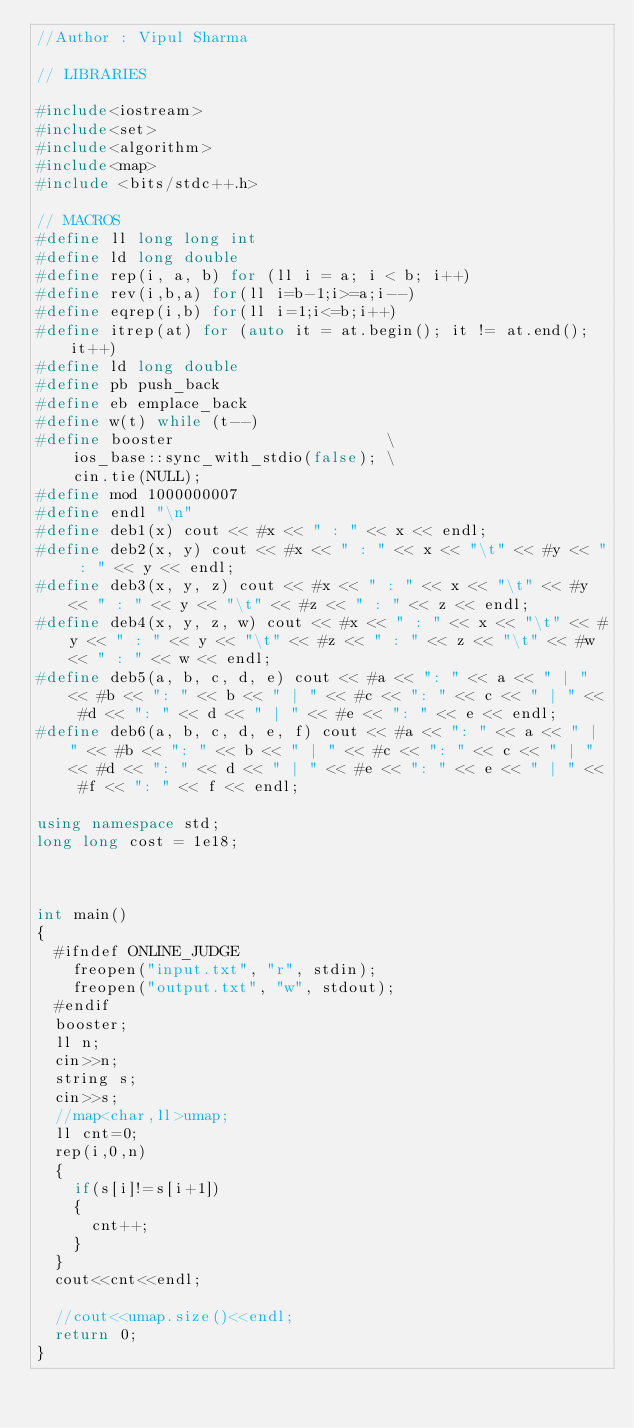<code> <loc_0><loc_0><loc_500><loc_500><_C++_>//Author : Vipul Sharma
 
// LIBRARIES

#include<iostream>
#include<set>
#include<algorithm>
#include<map>
#include <bits/stdc++.h>
 
// MACROS
#define ll long long int
#define ld long double
#define rep(i, a, b) for (ll i = a; i < b; i++)
#define rev(i,b,a) for(ll i=b-1;i>=a;i--)
#define eqrep(i,b) for(ll i=1;i<=b;i++)
#define itrep(at) for (auto it = at.begin(); it != at.end(); it++)
#define ld long double
#define pb push_back
#define eb emplace_back
#define w(t) while (t--)
#define booster                       \
    ios_base::sync_with_stdio(false); \
    cin.tie(NULL);
#define mod 1000000007
#define endl "\n"
#define deb1(x) cout << #x << " : " << x << endl;
#define deb2(x, y) cout << #x << " : " << x << "\t" << #y << " : " << y << endl;
#define deb3(x, y, z) cout << #x << " : " << x << "\t" << #y << " : " << y << "\t" << #z << " : " << z << endl;
#define deb4(x, y, z, w) cout << #x << " : " << x << "\t" << #y << " : " << y << "\t" << #z << " : " << z << "\t" << #w << " : " << w << endl;
#define deb5(a, b, c, d, e) cout << #a << ": " << a << " | " << #b << ": " << b << " | " << #c << ": " << c << " | " << #d << ": " << d << " | " << #e << ": " << e << endl;
#define deb6(a, b, c, d, e, f) cout << #a << ": " << a << " | " << #b << ": " << b << " | " << #c << ": " << c << " | " << #d << ": " << d << " | " << #e << ": " << e << " | " << #f << ": " << f << endl;
 
using namespace std;
long long cost = 1e18;
 
 
 
int main()
{
	#ifndef ONLINE_JUDGE
    freopen("input.txt", "r", stdin);
    freopen("output.txt", "w", stdout);
	#endif
	booster;
	ll n;
	cin>>n;
	string s;
	cin>>s;
	//map<char,ll>umap;
	ll cnt=0;
	rep(i,0,n)
	{
		if(s[i]!=s[i+1])
		{
			cnt++;
		}
	}
	cout<<cnt<<endl;

	//cout<<umap.size()<<endl;
	return 0;
}</code> 